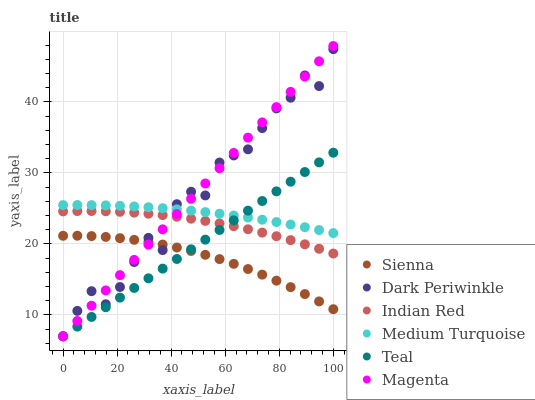Does Sienna have the minimum area under the curve?
Answer yes or no. Yes. Does Magenta have the maximum area under the curve?
Answer yes or no. Yes. Does Medium Turquoise have the minimum area under the curve?
Answer yes or no. No. Does Medium Turquoise have the maximum area under the curve?
Answer yes or no. No. Is Teal the smoothest?
Answer yes or no. Yes. Is Dark Periwinkle the roughest?
Answer yes or no. Yes. Is Sienna the smoothest?
Answer yes or no. No. Is Sienna the roughest?
Answer yes or no. No. Does Teal have the lowest value?
Answer yes or no. Yes. Does Sienna have the lowest value?
Answer yes or no. No. Does Magenta have the highest value?
Answer yes or no. Yes. Does Medium Turquoise have the highest value?
Answer yes or no. No. Is Indian Red less than Medium Turquoise?
Answer yes or no. Yes. Is Medium Turquoise greater than Indian Red?
Answer yes or no. Yes. Does Magenta intersect Teal?
Answer yes or no. Yes. Is Magenta less than Teal?
Answer yes or no. No. Is Magenta greater than Teal?
Answer yes or no. No. Does Indian Red intersect Medium Turquoise?
Answer yes or no. No. 